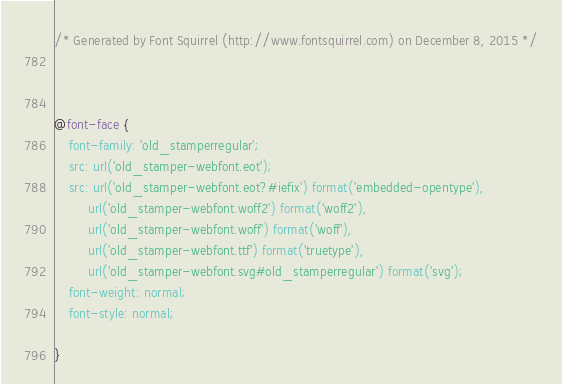Convert code to text. <code><loc_0><loc_0><loc_500><loc_500><_CSS_>/* Generated by Font Squirrel (http://www.fontsquirrel.com) on December 8, 2015 */



@font-face {
    font-family: 'old_stamperregular';
    src: url('old_stamper-webfont.eot');
    src: url('old_stamper-webfont.eot?#iefix') format('embedded-opentype'),
         url('old_stamper-webfont.woff2') format('woff2'),
         url('old_stamper-webfont.woff') format('woff'),
         url('old_stamper-webfont.ttf') format('truetype'),
         url('old_stamper-webfont.svg#old_stamperregular') format('svg');
    font-weight: normal;
    font-style: normal;

}</code> 